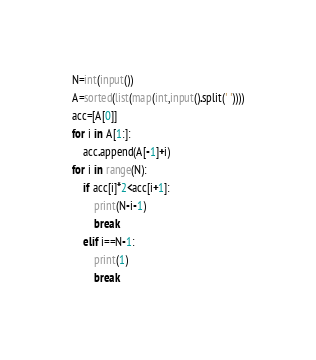<code> <loc_0><loc_0><loc_500><loc_500><_Python_>N=int(input())
A=sorted(list(map(int,input().split(' '))))
acc=[A[0]]
for i in A[1:]:
    acc.append(A[-1]+i)
for i in range(N):
    if acc[i]*2<acc[i+1]:
        print(N-i-1)
        break
    elif i==N-1:
        print(1)
        break</code> 